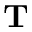Convert formula to latex. <formula><loc_0><loc_0><loc_500><loc_500>T</formula> 